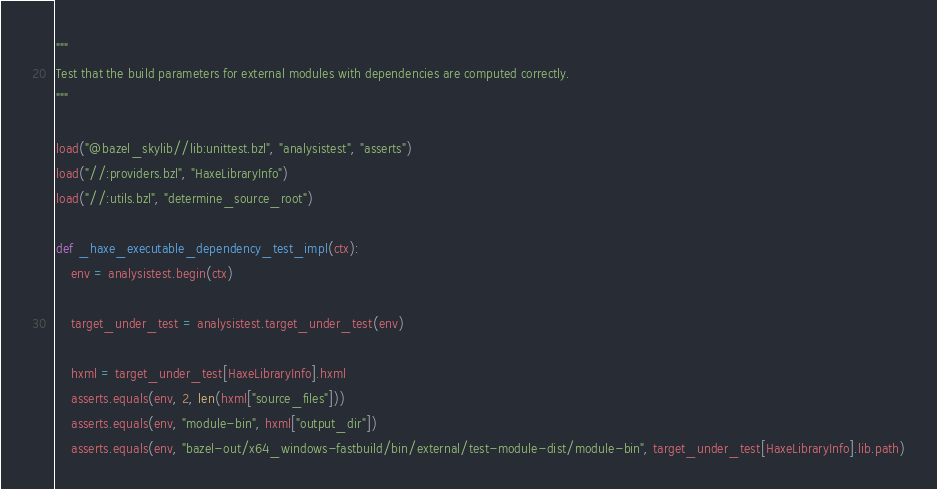<code> <loc_0><loc_0><loc_500><loc_500><_Python_>"""
Test that the build parameters for external modules with dependencies are computed correctly.
"""

load("@bazel_skylib//lib:unittest.bzl", "analysistest", "asserts")
load("//:providers.bzl", "HaxeLibraryInfo")
load("//:utils.bzl", "determine_source_root")

def _haxe_executable_dependency_test_impl(ctx):
    env = analysistest.begin(ctx)

    target_under_test = analysistest.target_under_test(env)

    hxml = target_under_test[HaxeLibraryInfo].hxml
    asserts.equals(env, 2, len(hxml["source_files"]))
    asserts.equals(env, "module-bin", hxml["output_dir"])
    asserts.equals(env, "bazel-out/x64_windows-fastbuild/bin/external/test-module-dist/module-bin", target_under_test[HaxeLibraryInfo].lib.path)</code> 